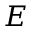<formula> <loc_0><loc_0><loc_500><loc_500>E</formula> 